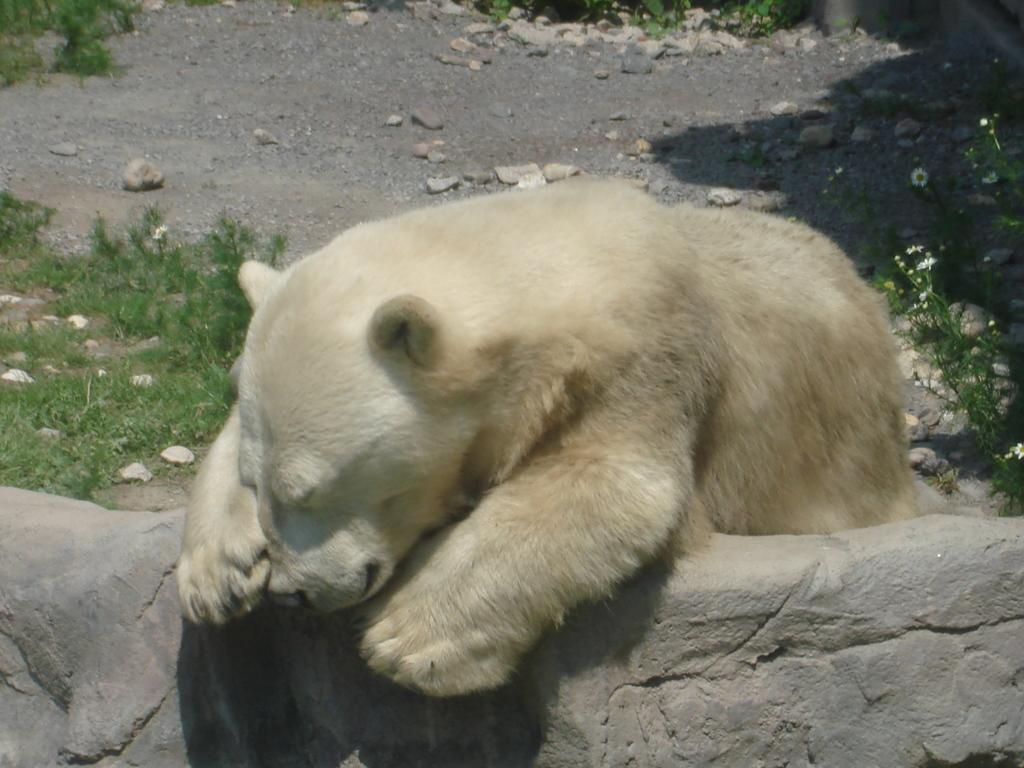What type of animal is in the image? There is a white color polar bear in the image. What can be seen on the ground in the image? There are stones on the ground in the image. What type of vegetation is present in the image? There are plants on the land in the image. How does the father interact with the calculator in the image? There is no father or calculator present in the image. 